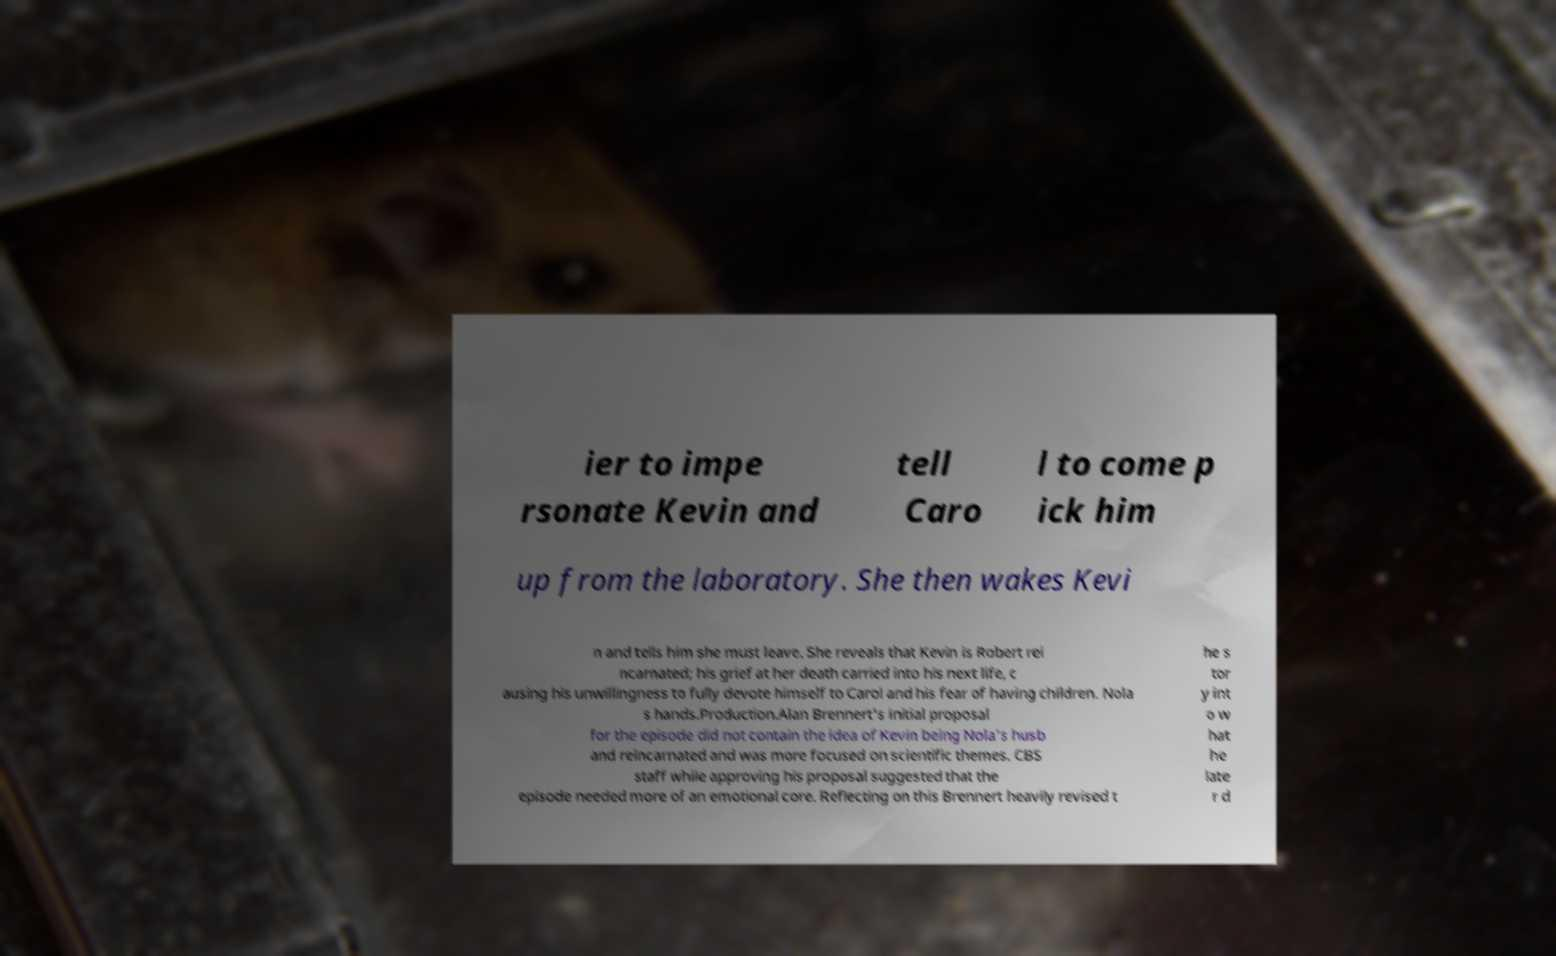Could you assist in decoding the text presented in this image and type it out clearly? ier to impe rsonate Kevin and tell Caro l to come p ick him up from the laboratory. She then wakes Kevi n and tells him she must leave. She reveals that Kevin is Robert rei ncarnated; his grief at her death carried into his next life, c ausing his unwillingness to fully devote himself to Carol and his fear of having children. Nola s hands.Production.Alan Brennert's initial proposal for the episode did not contain the idea of Kevin being Nola's husb and reincarnated and was more focused on scientific themes. CBS staff while approving his proposal suggested that the episode needed more of an emotional core. Reflecting on this Brennert heavily revised t he s tor y int o w hat he late r d 